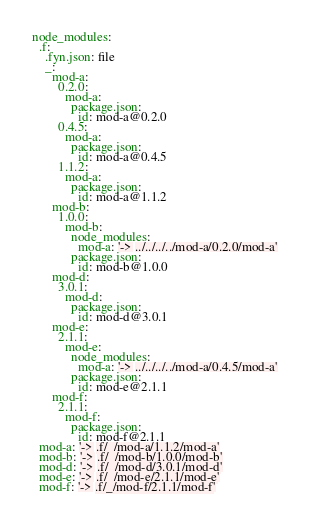<code> <loc_0><loc_0><loc_500><loc_500><_YAML_>node_modules:
  .f:
    .fyn.json: file
    _:
      mod-a:
        0.2.0:
          mod-a:
            package.json:
              id: mod-a@0.2.0
        0.4.5:
          mod-a:
            package.json:
              id: mod-a@0.4.5
        1.1.2:
          mod-a:
            package.json:
              id: mod-a@1.1.2
      mod-b:
        1.0.0:
          mod-b:
            node_modules:
              mod-a: '-> ../../../../mod-a/0.2.0/mod-a'
            package.json:
              id: mod-b@1.0.0
      mod-d:
        3.0.1:
          mod-d:
            package.json:
              id: mod-d@3.0.1
      mod-e:
        2.1.1:
          mod-e:
            node_modules:
              mod-a: '-> ../../../../mod-a/0.4.5/mod-a'
            package.json:
              id: mod-e@2.1.1
      mod-f:
        2.1.1:
          mod-f:
            package.json:
              id: mod-f@2.1.1
  mod-a: '-> .f/_/mod-a/1.1.2/mod-a'
  mod-b: '-> .f/_/mod-b/1.0.0/mod-b'
  mod-d: '-> .f/_/mod-d/3.0.1/mod-d'
  mod-e: '-> .f/_/mod-e/2.1.1/mod-e'
  mod-f: '-> .f/_/mod-f/2.1.1/mod-f'
</code> 